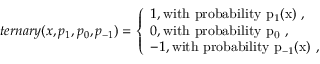<formula> <loc_0><loc_0><loc_500><loc_500>t e r n a r y ( x , p _ { 1 } , p _ { 0 } , p _ { - 1 } ) = \left \{ \begin{array} { l l } { 1 , w i t h p r o b a b i l i t y p _ { 1 } ( x ) , } \\ { 0 , w i t h p r o b a b i l i t y p _ { 0 } , } \\ { - 1 , w i t h p r o b a b i l i t y p _ { - 1 } ( x ) , } \end{array}</formula> 